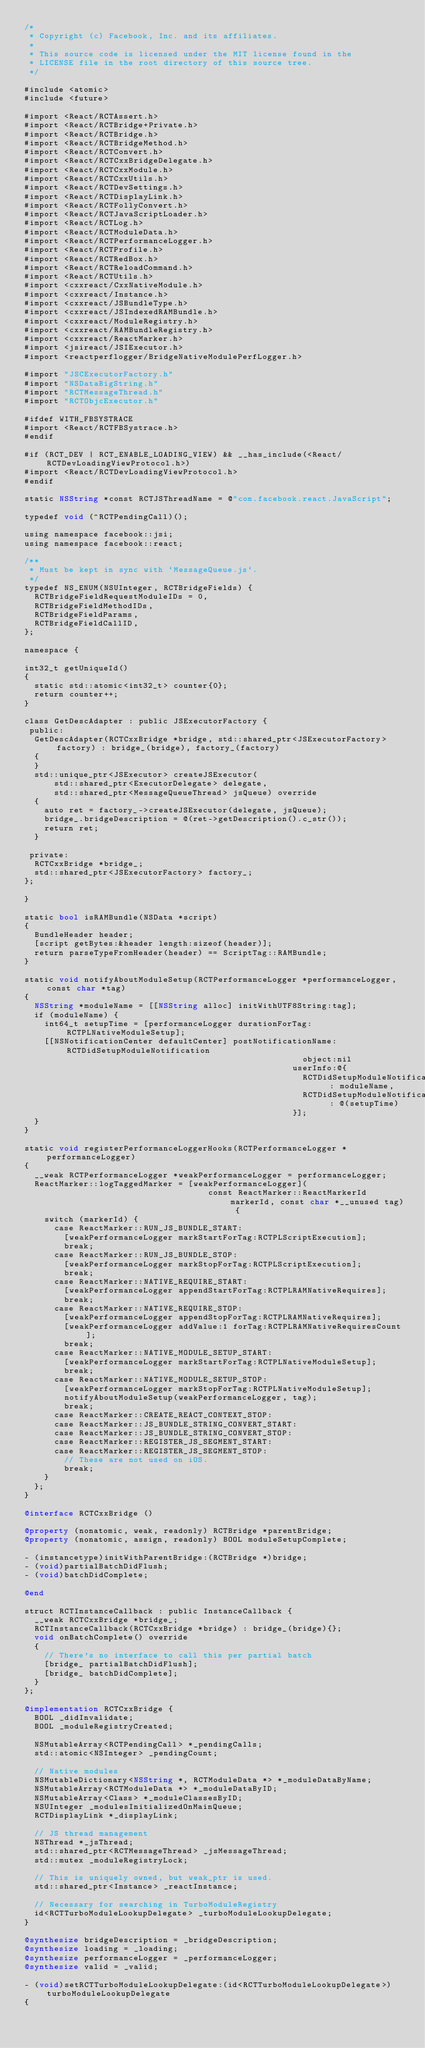Convert code to text. <code><loc_0><loc_0><loc_500><loc_500><_ObjectiveC_>/*
 * Copyright (c) Facebook, Inc. and its affiliates.
 *
 * This source code is licensed under the MIT license found in the
 * LICENSE file in the root directory of this source tree.
 */

#include <atomic>
#include <future>

#import <React/RCTAssert.h>
#import <React/RCTBridge+Private.h>
#import <React/RCTBridge.h>
#import <React/RCTBridgeMethod.h>
#import <React/RCTConvert.h>
#import <React/RCTCxxBridgeDelegate.h>
#import <React/RCTCxxModule.h>
#import <React/RCTCxxUtils.h>
#import <React/RCTDevSettings.h>
#import <React/RCTDisplayLink.h>
#import <React/RCTFollyConvert.h>
#import <React/RCTJavaScriptLoader.h>
#import <React/RCTLog.h>
#import <React/RCTModuleData.h>
#import <React/RCTPerformanceLogger.h>
#import <React/RCTProfile.h>
#import <React/RCTRedBox.h>
#import <React/RCTReloadCommand.h>
#import <React/RCTUtils.h>
#import <cxxreact/CxxNativeModule.h>
#import <cxxreact/Instance.h>
#import <cxxreact/JSBundleType.h>
#import <cxxreact/JSIndexedRAMBundle.h>
#import <cxxreact/ModuleRegistry.h>
#import <cxxreact/RAMBundleRegistry.h>
#import <cxxreact/ReactMarker.h>
#import <jsireact/JSIExecutor.h>
#import <reactperflogger/BridgeNativeModulePerfLogger.h>

#import "JSCExecutorFactory.h"
#import "NSDataBigString.h"
#import "RCTMessageThread.h"
#import "RCTObjcExecutor.h"

#ifdef WITH_FBSYSTRACE
#import <React/RCTFBSystrace.h>
#endif

#if (RCT_DEV | RCT_ENABLE_LOADING_VIEW) && __has_include(<React/RCTDevLoadingViewProtocol.h>)
#import <React/RCTDevLoadingViewProtocol.h>
#endif

static NSString *const RCTJSThreadName = @"com.facebook.react.JavaScript";

typedef void (^RCTPendingCall)();

using namespace facebook::jsi;
using namespace facebook::react;

/**
 * Must be kept in sync with `MessageQueue.js`.
 */
typedef NS_ENUM(NSUInteger, RCTBridgeFields) {
  RCTBridgeFieldRequestModuleIDs = 0,
  RCTBridgeFieldMethodIDs,
  RCTBridgeFieldParams,
  RCTBridgeFieldCallID,
};

namespace {

int32_t getUniqueId()
{
  static std::atomic<int32_t> counter{0};
  return counter++;
}

class GetDescAdapter : public JSExecutorFactory {
 public:
  GetDescAdapter(RCTCxxBridge *bridge, std::shared_ptr<JSExecutorFactory> factory) : bridge_(bridge), factory_(factory)
  {
  }
  std::unique_ptr<JSExecutor> createJSExecutor(
      std::shared_ptr<ExecutorDelegate> delegate,
      std::shared_ptr<MessageQueueThread> jsQueue) override
  {
    auto ret = factory_->createJSExecutor(delegate, jsQueue);
    bridge_.bridgeDescription = @(ret->getDescription().c_str());
    return ret;
  }

 private:
  RCTCxxBridge *bridge_;
  std::shared_ptr<JSExecutorFactory> factory_;
};

}

static bool isRAMBundle(NSData *script)
{
  BundleHeader header;
  [script getBytes:&header length:sizeof(header)];
  return parseTypeFromHeader(header) == ScriptTag::RAMBundle;
}

static void notifyAboutModuleSetup(RCTPerformanceLogger *performanceLogger, const char *tag)
{
  NSString *moduleName = [[NSString alloc] initWithUTF8String:tag];
  if (moduleName) {
    int64_t setupTime = [performanceLogger durationForTag:RCTPLNativeModuleSetup];
    [[NSNotificationCenter defaultCenter] postNotificationName:RCTDidSetupModuleNotification
                                                        object:nil
                                                      userInfo:@{
                                                        RCTDidSetupModuleNotificationModuleNameKey : moduleName,
                                                        RCTDidSetupModuleNotificationSetupTimeKey : @(setupTime)
                                                      }];
  }
}

static void registerPerformanceLoggerHooks(RCTPerformanceLogger *performanceLogger)
{
  __weak RCTPerformanceLogger *weakPerformanceLogger = performanceLogger;
  ReactMarker::logTaggedMarker = [weakPerformanceLogger](
                                     const ReactMarker::ReactMarkerId markerId, const char *__unused tag) {
    switch (markerId) {
      case ReactMarker::RUN_JS_BUNDLE_START:
        [weakPerformanceLogger markStartForTag:RCTPLScriptExecution];
        break;
      case ReactMarker::RUN_JS_BUNDLE_STOP:
        [weakPerformanceLogger markStopForTag:RCTPLScriptExecution];
        break;
      case ReactMarker::NATIVE_REQUIRE_START:
        [weakPerformanceLogger appendStartForTag:RCTPLRAMNativeRequires];
        break;
      case ReactMarker::NATIVE_REQUIRE_STOP:
        [weakPerformanceLogger appendStopForTag:RCTPLRAMNativeRequires];
        [weakPerformanceLogger addValue:1 forTag:RCTPLRAMNativeRequiresCount];
        break;
      case ReactMarker::NATIVE_MODULE_SETUP_START:
        [weakPerformanceLogger markStartForTag:RCTPLNativeModuleSetup];
        break;
      case ReactMarker::NATIVE_MODULE_SETUP_STOP:
        [weakPerformanceLogger markStopForTag:RCTPLNativeModuleSetup];
        notifyAboutModuleSetup(weakPerformanceLogger, tag);
        break;
      case ReactMarker::CREATE_REACT_CONTEXT_STOP:
      case ReactMarker::JS_BUNDLE_STRING_CONVERT_START:
      case ReactMarker::JS_BUNDLE_STRING_CONVERT_STOP:
      case ReactMarker::REGISTER_JS_SEGMENT_START:
      case ReactMarker::REGISTER_JS_SEGMENT_STOP:
        // These are not used on iOS.
        break;
    }
  };
}

@interface RCTCxxBridge ()

@property (nonatomic, weak, readonly) RCTBridge *parentBridge;
@property (nonatomic, assign, readonly) BOOL moduleSetupComplete;

- (instancetype)initWithParentBridge:(RCTBridge *)bridge;
- (void)partialBatchDidFlush;
- (void)batchDidComplete;

@end

struct RCTInstanceCallback : public InstanceCallback {
  __weak RCTCxxBridge *bridge_;
  RCTInstanceCallback(RCTCxxBridge *bridge) : bridge_(bridge){};
  void onBatchComplete() override
  {
    // There's no interface to call this per partial batch
    [bridge_ partialBatchDidFlush];
    [bridge_ batchDidComplete];
  }
};

@implementation RCTCxxBridge {
  BOOL _didInvalidate;
  BOOL _moduleRegistryCreated;

  NSMutableArray<RCTPendingCall> *_pendingCalls;
  std::atomic<NSInteger> _pendingCount;

  // Native modules
  NSMutableDictionary<NSString *, RCTModuleData *> *_moduleDataByName;
  NSMutableArray<RCTModuleData *> *_moduleDataByID;
  NSMutableArray<Class> *_moduleClassesByID;
  NSUInteger _modulesInitializedOnMainQueue;
  RCTDisplayLink *_displayLink;

  // JS thread management
  NSThread *_jsThread;
  std::shared_ptr<RCTMessageThread> _jsMessageThread;
  std::mutex _moduleRegistryLock;

  // This is uniquely owned, but weak_ptr is used.
  std::shared_ptr<Instance> _reactInstance;

  // Necessary for searching in TurboModuleRegistry
  id<RCTTurboModuleLookupDelegate> _turboModuleLookupDelegate;
}

@synthesize bridgeDescription = _bridgeDescription;
@synthesize loading = _loading;
@synthesize performanceLogger = _performanceLogger;
@synthesize valid = _valid;

- (void)setRCTTurboModuleLookupDelegate:(id<RCTTurboModuleLookupDelegate>)turboModuleLookupDelegate
{</code> 